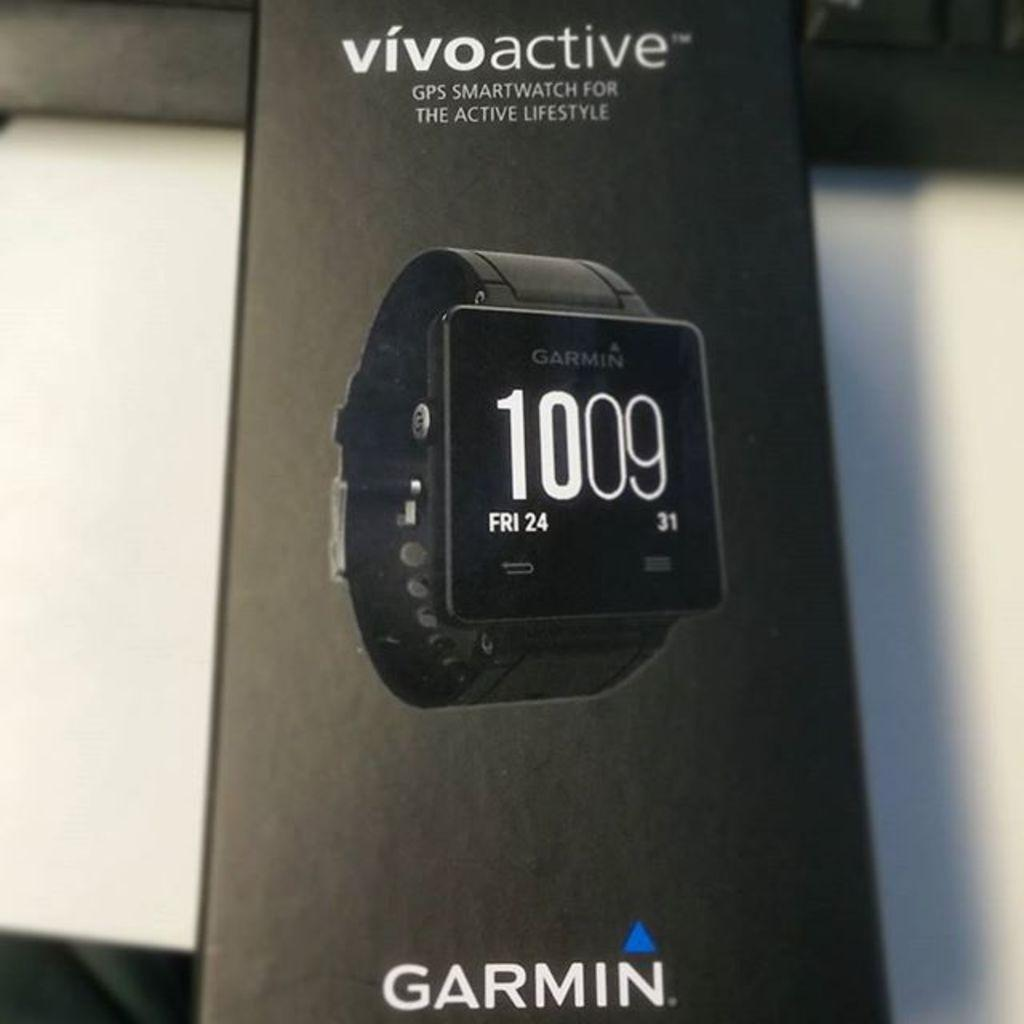Provide a one-sentence caption for the provided image. A display for a Garmin fintess watch which proclaims it is for the active lifestyle. 